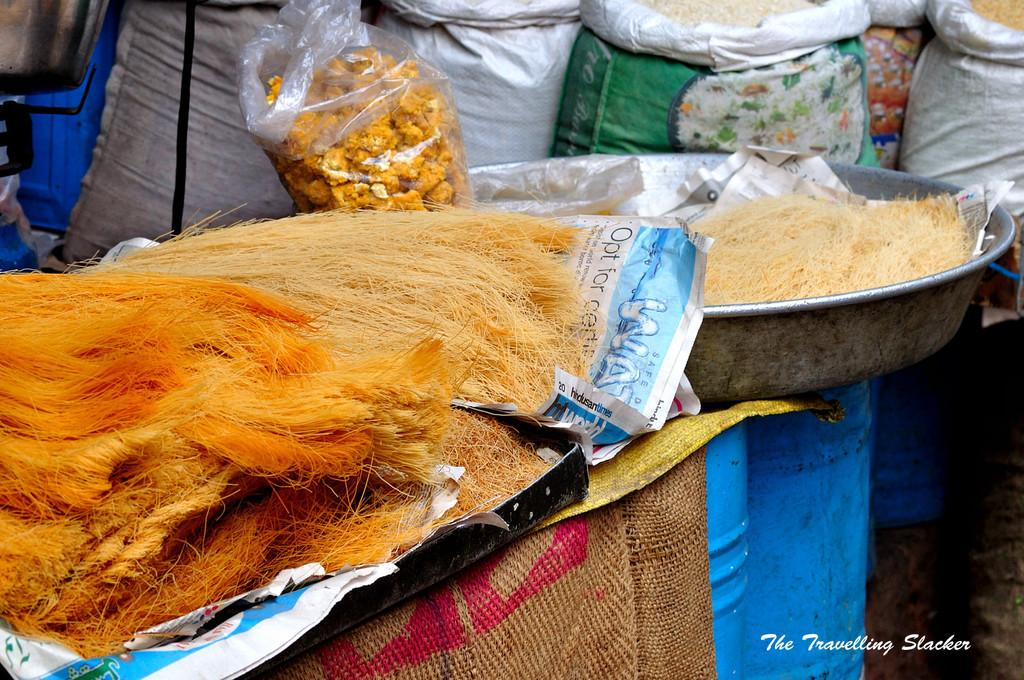What type of objects are present in large quantity in the image? There are bambinos in the image, and they are in large quantity. Where are the bambinos located in the image? The bambinos are on a table in the image. What else can be seen in the image besides the bambinos? There are grains bags in the image. When was the image taken? The image was taken during the day. Where was the image taken? The image was taken in a market. How many beds can be seen in the image? There are no beds present in the image. Is there a bear visible in the image? There is no bear present in the image. 